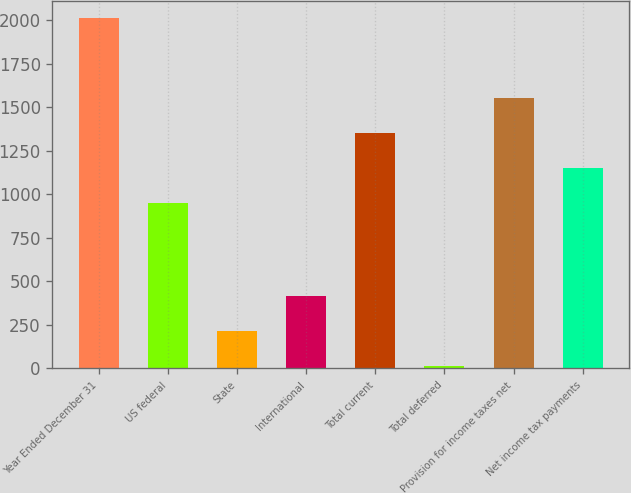Convert chart. <chart><loc_0><loc_0><loc_500><loc_500><bar_chart><fcel>Year Ended December 31<fcel>US federal<fcel>State<fcel>International<fcel>Total current<fcel>Total deferred<fcel>Provision for income taxes net<fcel>Net income tax payments<nl><fcel>2011<fcel>951<fcel>213.7<fcel>413.4<fcel>1350.4<fcel>14<fcel>1550.1<fcel>1150.7<nl></chart> 